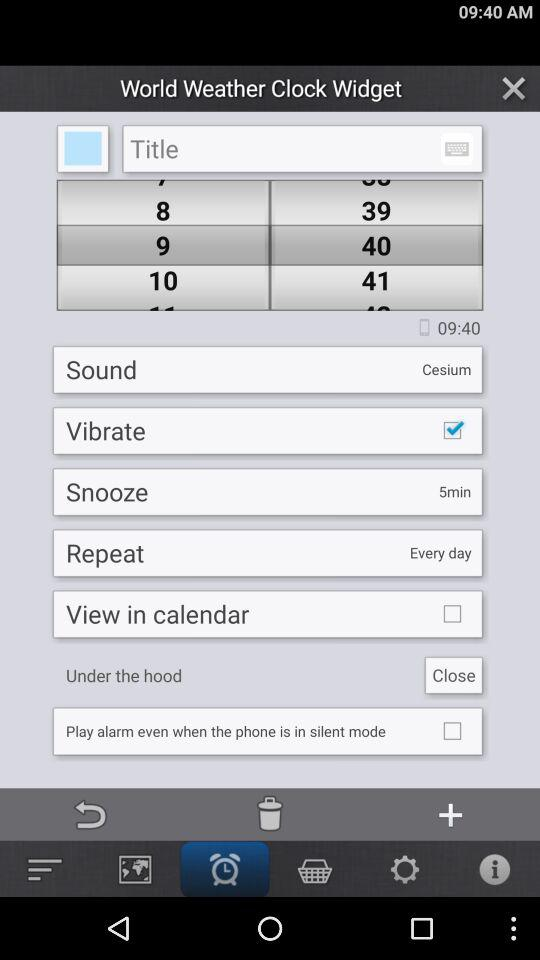What is the snooze time? The snooze time is 5 minutes. 